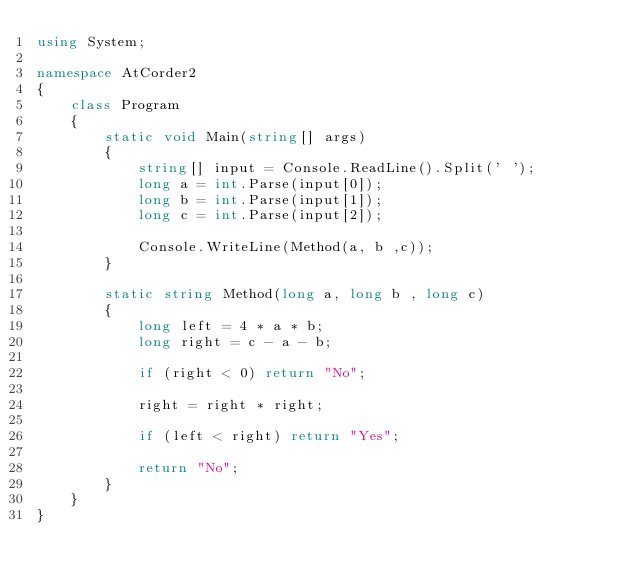<code> <loc_0><loc_0><loc_500><loc_500><_C#_>using System;

namespace AtCorder2
{
    class Program
    {
        static void Main(string[] args)
        {
            string[] input = Console.ReadLine().Split(' ');
            long a = int.Parse(input[0]);
            long b = int.Parse(input[1]);
            long c = int.Parse(input[2]);

            Console.WriteLine(Method(a, b ,c));
        }

        static string Method(long a, long b , long c)
        {
            long left = 4 * a * b;
            long right = c - a - b;

            if (right < 0) return "No";

            right = right * right;

            if (left < right) return "Yes";

            return "No";
        }
    }
}
</code> 